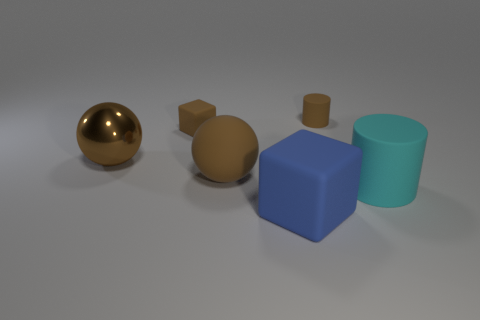There is a rubber cylinder behind the brown thing that is to the left of the brown rubber block; what is its color?
Provide a succinct answer. Brown. There is another matte object that is the same shape as the large blue object; what is its size?
Your response must be concise. Small. Do the big matte cylinder and the large matte sphere have the same color?
Your answer should be compact. No. How many blue matte objects are on the left side of the tiny object to the left of the matte block that is in front of the brown metallic thing?
Offer a very short reply. 0. Are there more brown shiny spheres than brown metal cylinders?
Provide a succinct answer. Yes. What number of small cyan metal spheres are there?
Ensure brevity in your answer.  0. There is a matte thing that is in front of the cyan object to the right of the cylinder that is on the left side of the cyan rubber cylinder; what is its shape?
Keep it short and to the point. Cube. Is the number of large blue objects in front of the brown metallic thing less than the number of big objects on the right side of the small brown cube?
Give a very brief answer. Yes. There is a tiny brown thing on the left side of the big blue matte cube; is it the same shape as the big rubber thing that is in front of the cyan cylinder?
Give a very brief answer. Yes. There is a tiny brown rubber thing that is in front of the brown matte thing that is right of the large rubber block; what is its shape?
Give a very brief answer. Cube. 